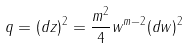Convert formula to latex. <formula><loc_0><loc_0><loc_500><loc_500>q = ( d z ) ^ { 2 } = \frac { m ^ { 2 } } { 4 } w ^ { m - 2 } ( d w ) ^ { 2 }</formula> 